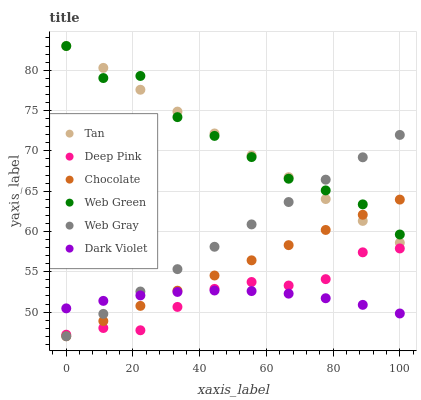Does Dark Violet have the minimum area under the curve?
Answer yes or no. Yes. Does Web Green have the maximum area under the curve?
Answer yes or no. Yes. Does Chocolate have the minimum area under the curve?
Answer yes or no. No. Does Chocolate have the maximum area under the curve?
Answer yes or no. No. Is Chocolate the smoothest?
Answer yes or no. Yes. Is Web Green the roughest?
Answer yes or no. Yes. Is Dark Violet the smoothest?
Answer yes or no. No. Is Dark Violet the roughest?
Answer yes or no. No. Does Chocolate have the lowest value?
Answer yes or no. Yes. Does Dark Violet have the lowest value?
Answer yes or no. No. Does Tan have the highest value?
Answer yes or no. Yes. Does Chocolate have the highest value?
Answer yes or no. No. Is Dark Violet less than Tan?
Answer yes or no. Yes. Is Tan greater than Deep Pink?
Answer yes or no. Yes. Does Tan intersect Web Green?
Answer yes or no. Yes. Is Tan less than Web Green?
Answer yes or no. No. Is Tan greater than Web Green?
Answer yes or no. No. Does Dark Violet intersect Tan?
Answer yes or no. No. 